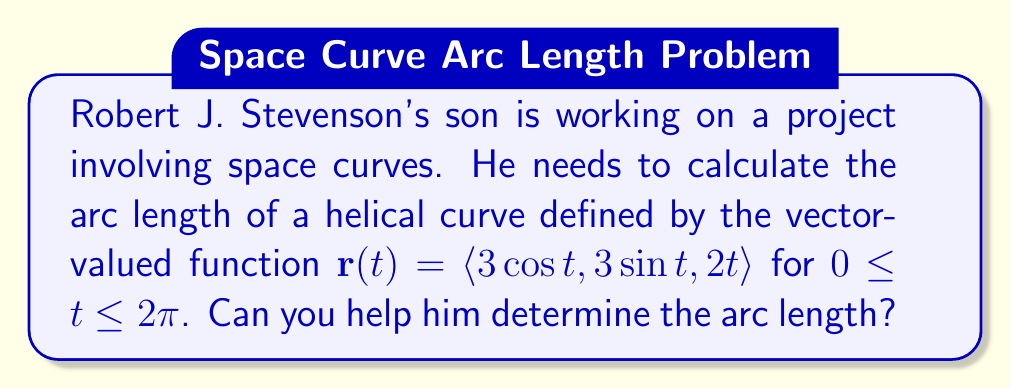What is the answer to this math problem? To compute the arc length of a space curve defined by a vector-valued function $\mathbf{r}(t)$ over an interval $[a, b]$, we use the formula:

$$L = \int_a^b |\mathbf{r}'(t)| dt$$

Where $\mathbf{r}'(t)$ is the derivative of the vector-valued function.

Steps:
1) First, we need to find $\mathbf{r}'(t)$:
   $$\mathbf{r}'(t) = \langle -3\sin t, 3\cos t, 2 \rangle$$

2) Next, we calculate $|\mathbf{r}'(t)|$:
   $$|\mathbf{r}'(t)| = \sqrt{(-3\sin t)^2 + (3\cos t)^2 + 2^2}$$
   $$= \sqrt{9\sin^2 t + 9\cos^2 t + 4}$$
   $$= \sqrt{9(\sin^2 t + \cos^2 t) + 4}$$
   $$= \sqrt{9 + 4} = \sqrt{13}$$

3) Now we can set up our integral:
   $$L = \int_0^{2\pi} \sqrt{13} dt$$

4) Since $\sqrt{13}$ is a constant, we can take it out of the integral:
   $$L = \sqrt{13} \int_0^{2\pi} dt$$

5) Evaluate the integral:
   $$L = \sqrt{13} [t]_0^{2\pi} = \sqrt{13} (2\pi - 0) = 2\pi\sqrt{13}$$

Therefore, the arc length of the helical curve is $2\pi\sqrt{13}$.
Answer: $2\pi\sqrt{13}$ 